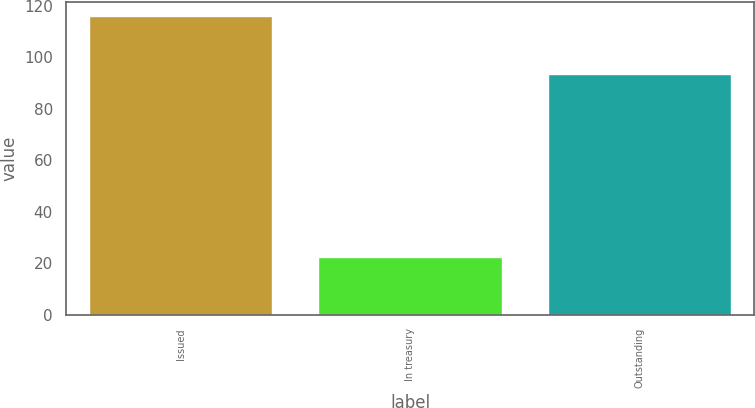<chart> <loc_0><loc_0><loc_500><loc_500><bar_chart><fcel>Issued<fcel>In treasury<fcel>Outstanding<nl><fcel>115.8<fcel>22.3<fcel>93.5<nl></chart> 